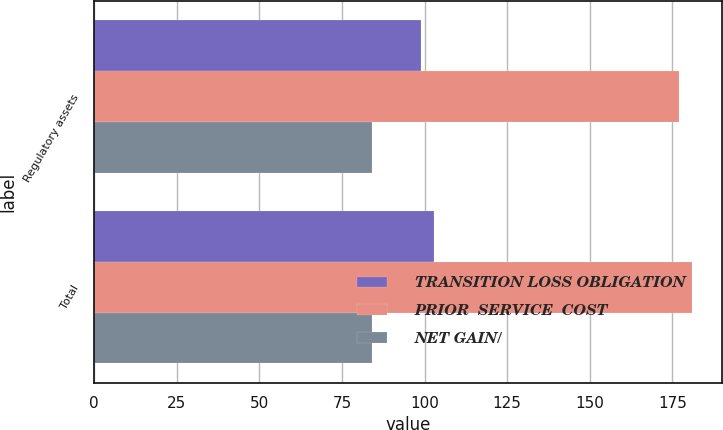Convert chart. <chart><loc_0><loc_0><loc_500><loc_500><stacked_bar_chart><ecel><fcel>Regulatory assets<fcel>Total<nl><fcel>TRANSITION LOSS OBLIGATION<fcel>99<fcel>103<nl><fcel>PRIOR  SERVICE  COST<fcel>177<fcel>181<nl><fcel>NET GAIN/<fcel>84<fcel>84<nl></chart> 